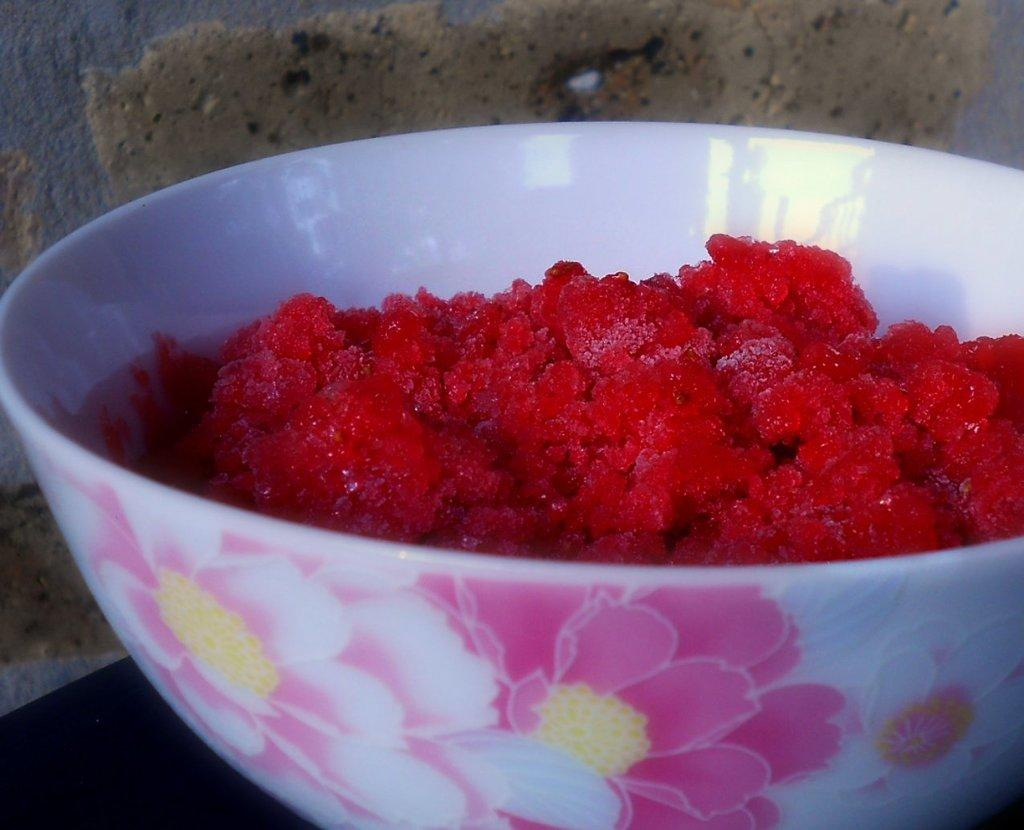What is in the cup that is visible in the image? There is a cup containing sweet in the image. Where is the cup located in the image? The cup is on a table in the image. What can be seen in the background of the image? There is a wall in the background of the image. What type of twig is being used to stir the soda in the image? There is no soda or twig present in the image. Can you tell me the order in which the items were placed on the table in the image? The provided facts do not give information about the order in which the items were placed on the table. 